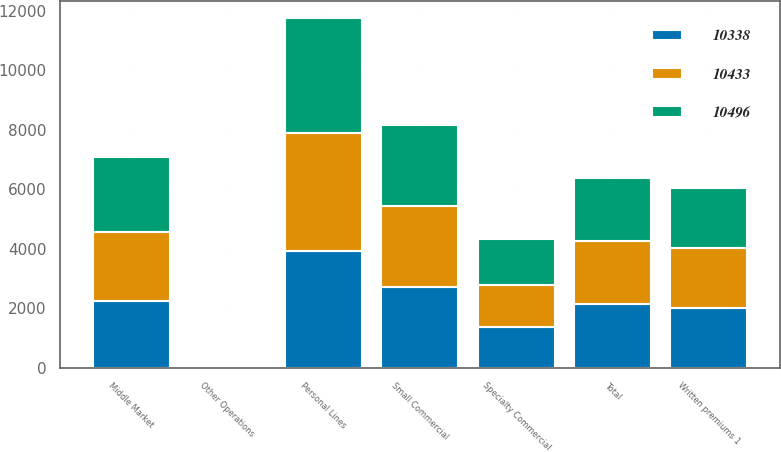<chart> <loc_0><loc_0><loc_500><loc_500><stacked_bar_chart><ecel><fcel>Written premiums 1<fcel>Personal Lines<fcel>Small Commercial<fcel>Middle Market<fcel>Specialty Commercial<fcel>Other Operations<fcel>Total<nl><fcel>10338<fcel>2008<fcel>3925<fcel>2696<fcel>2242<fcel>1361<fcel>7<fcel>2125<nl><fcel>10433<fcel>2007<fcel>3947<fcel>2747<fcel>2326<fcel>1415<fcel>5<fcel>2125<nl><fcel>10496<fcel>2006<fcel>3877<fcel>2728<fcel>2515<fcel>1538<fcel>4<fcel>2125<nl></chart> 